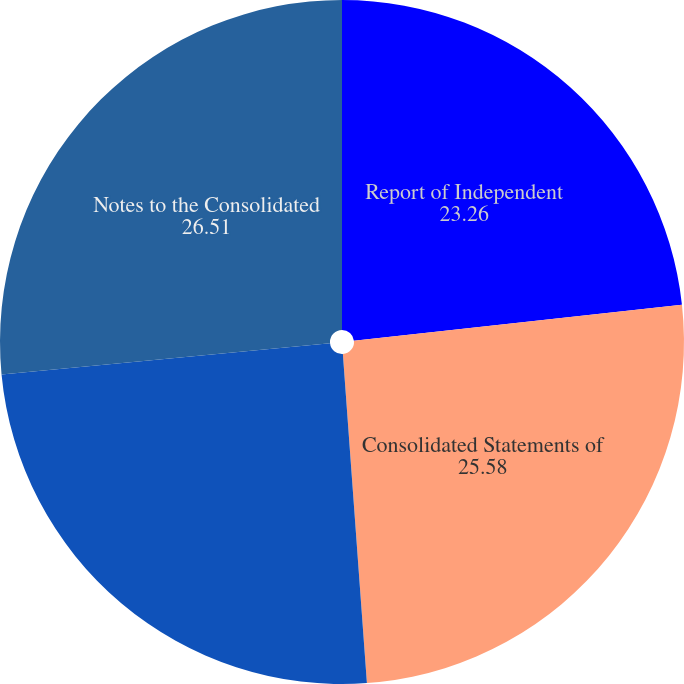Convert chart. <chart><loc_0><loc_0><loc_500><loc_500><pie_chart><fcel>Report of Independent<fcel>Consolidated Statements of<fcel>Consolidated Balance Sheets at<fcel>Notes to the Consolidated<nl><fcel>23.26%<fcel>25.58%<fcel>24.65%<fcel>26.51%<nl></chart> 